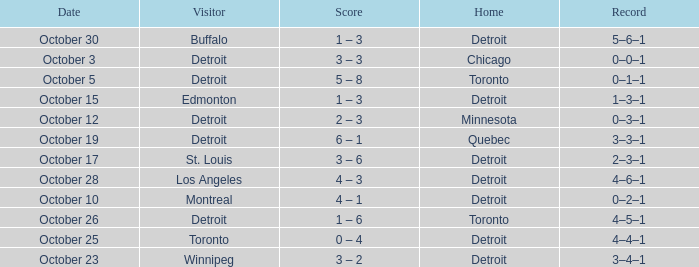Name the home with toronto visiting Detroit. 